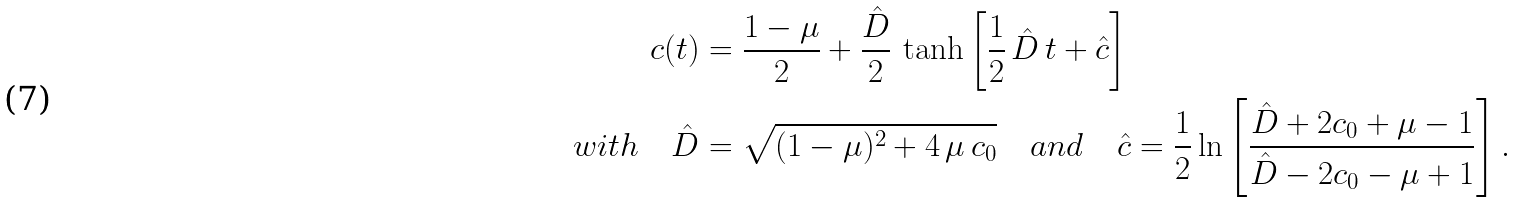Convert formula to latex. <formula><loc_0><loc_0><loc_500><loc_500>c ( t ) & = \frac { 1 - \mu } { 2 } + \frac { \hat { D } } { 2 } \, \tanh \left [ \frac { 1 } { 2 } \, \hat { D } \, t + \hat { c } \right ] \\ w i t h \quad \hat { D } & = \sqrt { ( 1 - \mu ) ^ { 2 } + 4 \, \mu \, c _ { 0 } } \quad a n d \quad \hat { c } = \frac { 1 } { 2 } \ln \left [ \frac { \hat { D } + 2 c _ { 0 } + \mu - 1 } { \hat { D } - 2 c _ { 0 } - \mu + 1 } \right ] .</formula> 